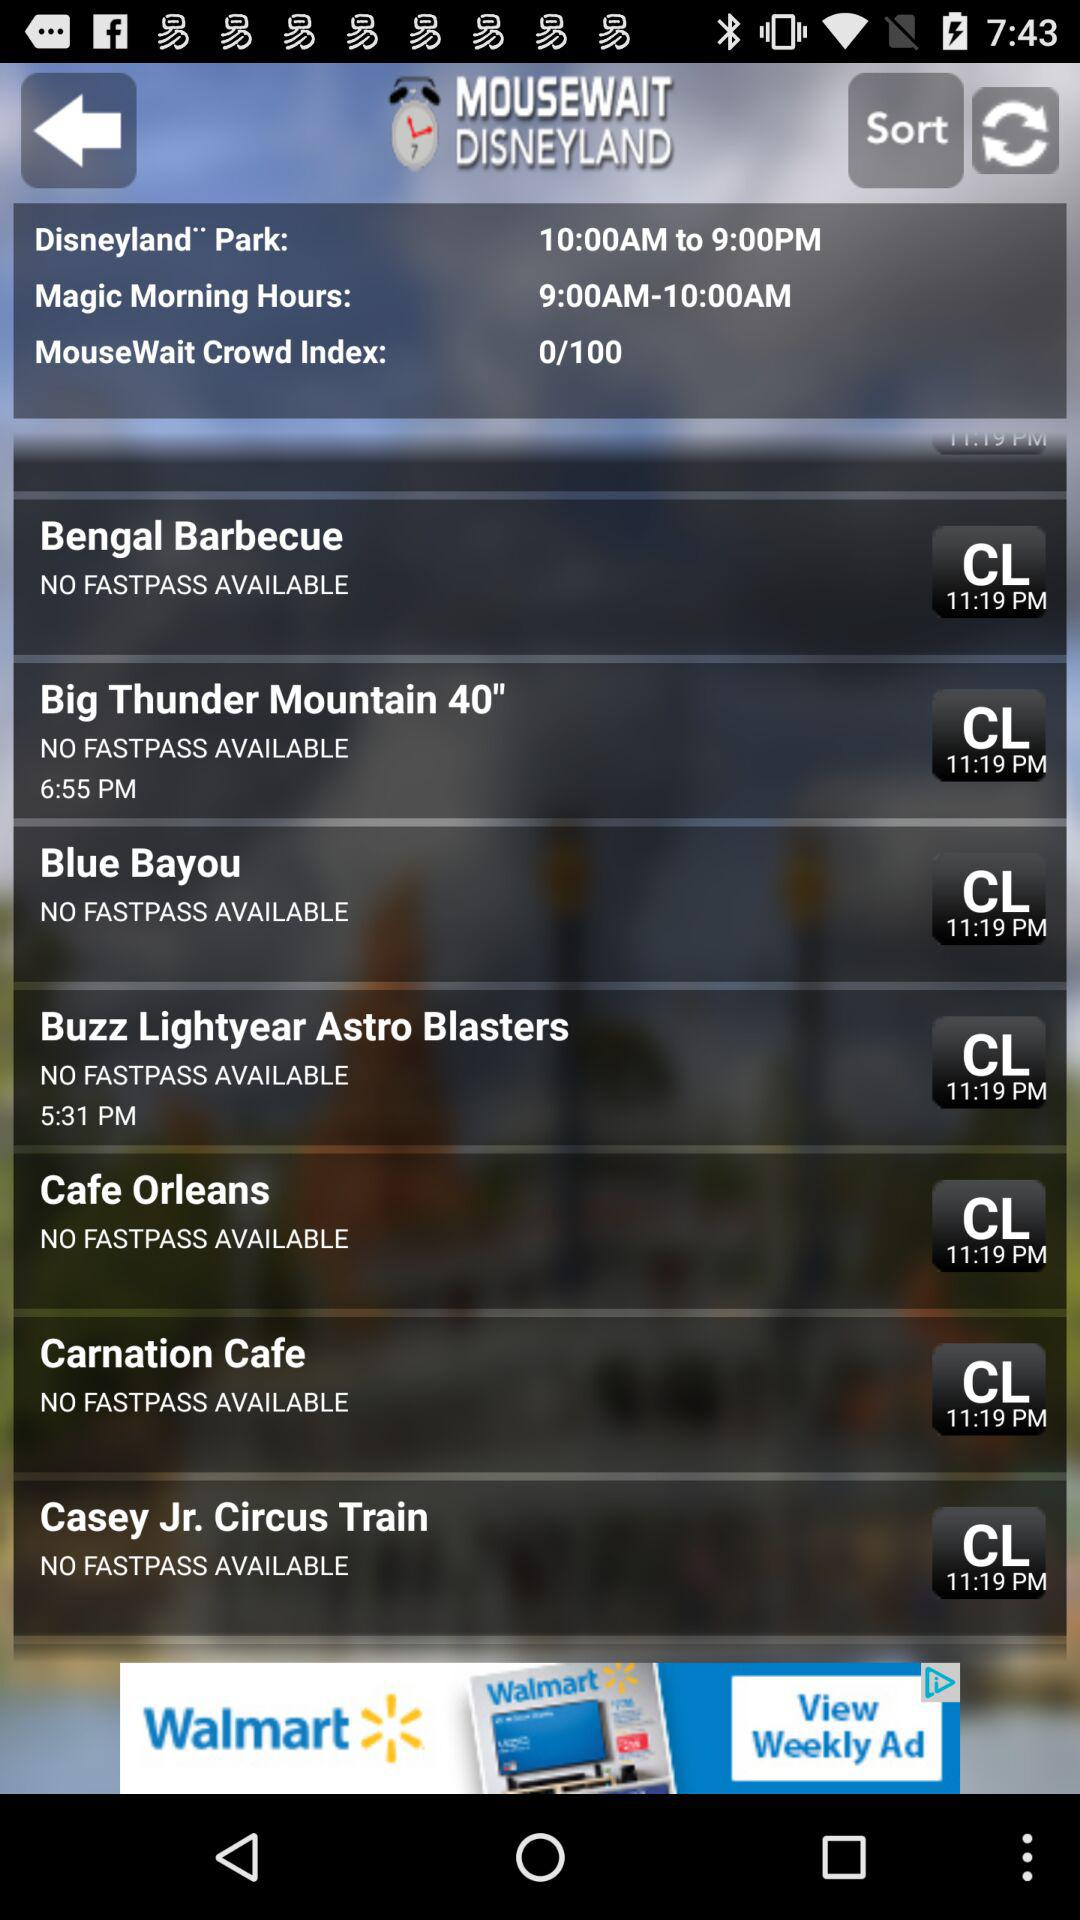What's the "MouseWait" crowd index? The "MouseWait" crowd index is 0/100. 